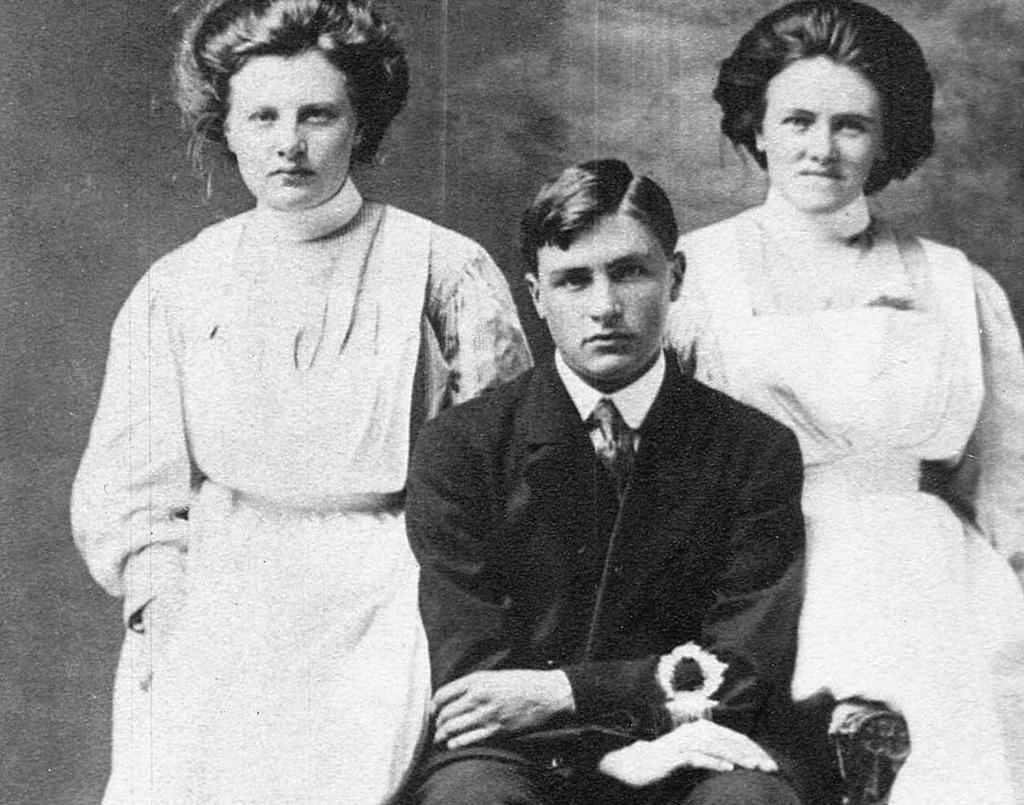Could you give a brief overview of what you see in this image? This is a black and white image. Here I can see a man sitting on the chair. On the both sides two women are standing. These are giving pose for the picture. 